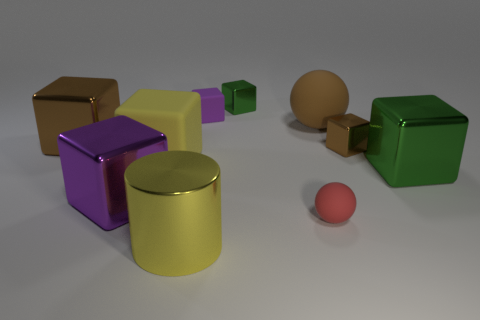Subtract all big matte cubes. How many cubes are left? 6 Subtract all cubes. How many objects are left? 3 Subtract all red balls. How many balls are left? 1 Add 6 large purple blocks. How many large purple blocks are left? 7 Add 3 large purple metal cubes. How many large purple metal cubes exist? 4 Subtract 0 gray cylinders. How many objects are left? 10 Subtract 7 cubes. How many cubes are left? 0 Subtract all blue spheres. Subtract all blue blocks. How many spheres are left? 2 Subtract all purple spheres. How many gray cubes are left? 0 Subtract all tiny brown metal cylinders. Subtract all big green shiny things. How many objects are left? 9 